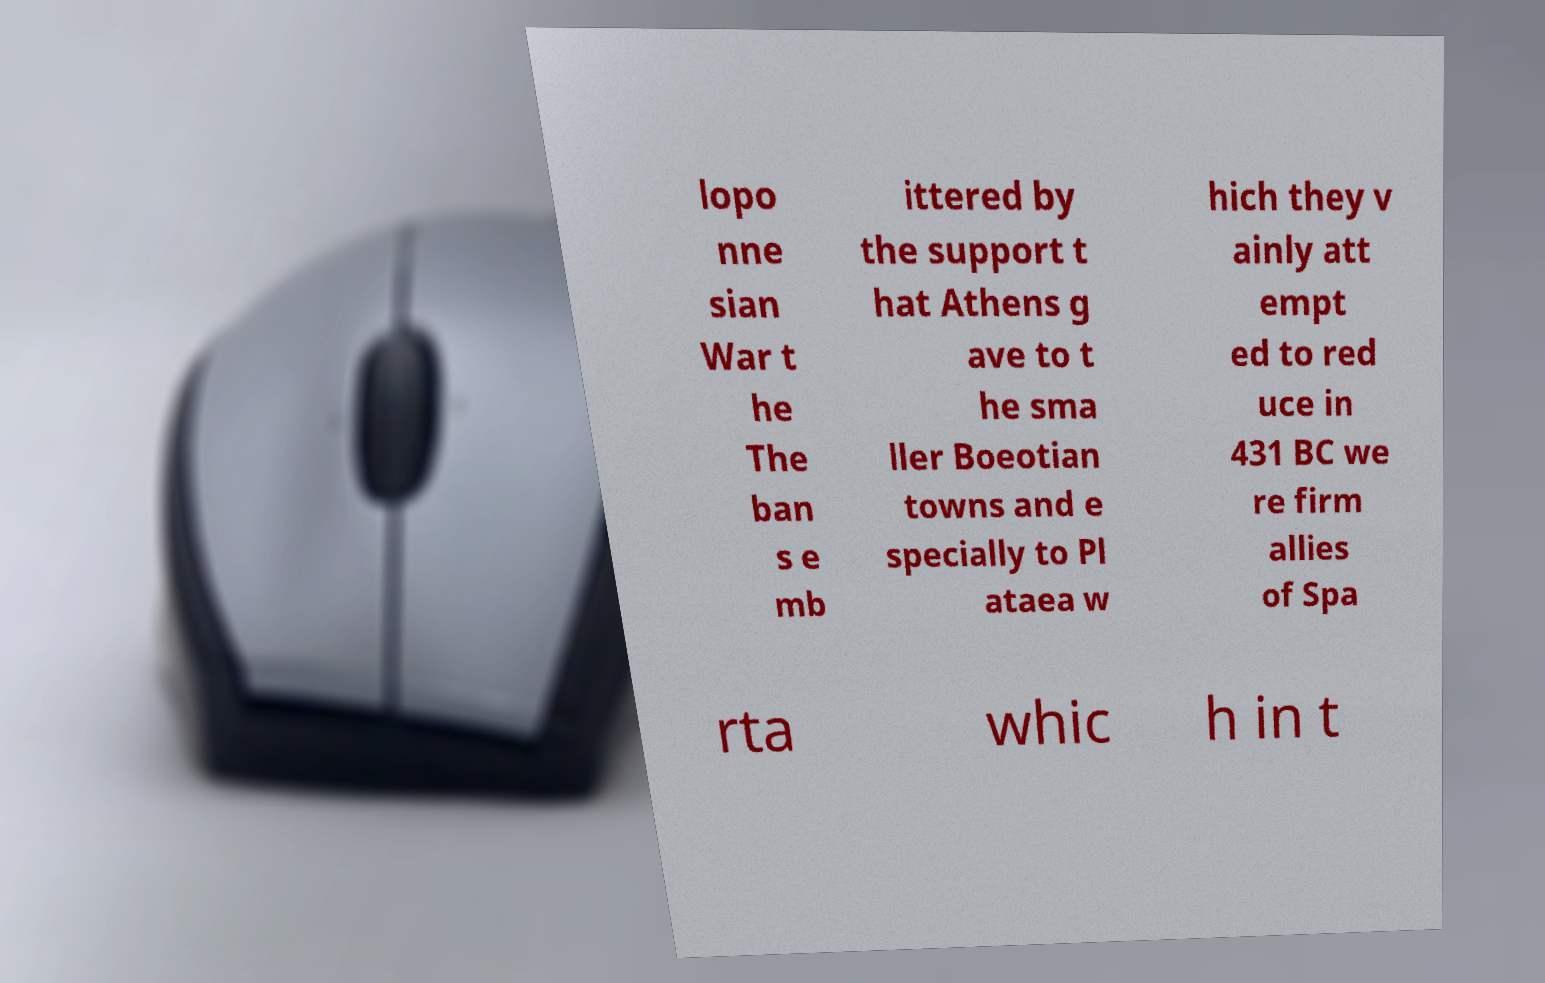For documentation purposes, I need the text within this image transcribed. Could you provide that? lopo nne sian War t he The ban s e mb ittered by the support t hat Athens g ave to t he sma ller Boeotian towns and e specially to Pl ataea w hich they v ainly att empt ed to red uce in 431 BC we re firm allies of Spa rta whic h in t 